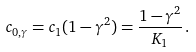<formula> <loc_0><loc_0><loc_500><loc_500>c _ { 0 , \gamma } = { c _ { 1 } } ( 1 - \gamma ^ { 2 } ) = \frac { 1 - \gamma ^ { 2 } } { K _ { 1 } } \, .</formula> 